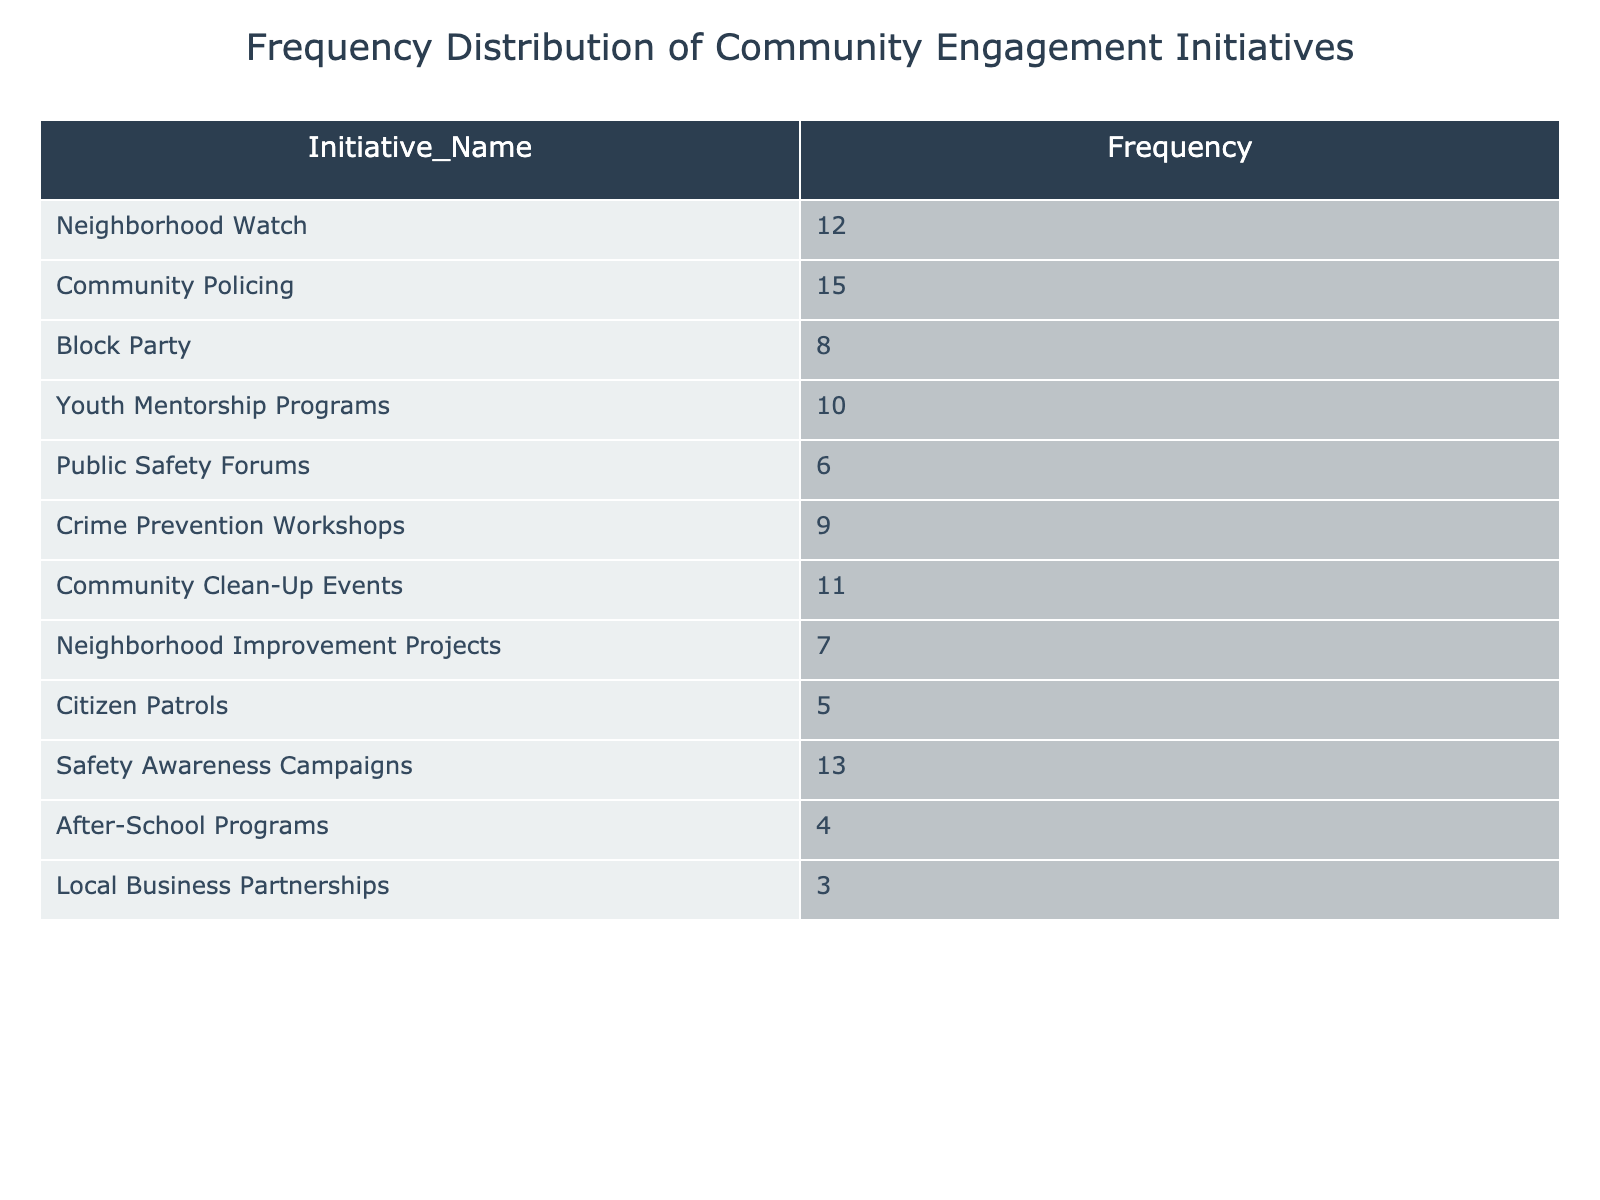What is the initiative with the highest frequency? By inspecting the 'Frequency' column, we can find that 'Community Policing' has the highest frequency value of 15, indicating it is the most engaged initiative.
Answer: Community Policing How many initiatives have a frequency of 10 or more? We can filter the initiatives with a frequency of 10 or more by looking at each value in the 'Frequency' column. The eligible initiatives are 'Neighborhood Watch', 'Community Policing', 'Safety Awareness Campaigns', 'Youth Mentorship Programs', and 'Community Clean-Up Events', totaling 5.
Answer: 5 What is the difference in frequency between the most and least frequent initiatives? The most frequent initiative is 'Community Policing' with a frequency of 15, and the least frequent initiative is 'Local Business Partnerships' with a frequency of 3. The difference is calculated as 15 - 3 = 12.
Answer: 12 Is there an initiative with a frequency equal to the median frequency of all initiatives? To find if there is an initiative with a frequency equal to the median, first, we list frequencies: 3, 4, 5, 6, 7, 8, 9, 10, 11, 12, 13, 15. There are 12 values, so the median is the average of 9 and 10, which is 9.5. The closest frequencies are 9 (Crime Prevention Workshops) and 10 (Youth Mentorship Programs). Therefore, no initiative has a frequency exactly equal to the median.
Answer: No What percentage of the total initiatives does the 'Block Party' represent? First, we sum all the frequencies: 12 + 15 + 8 + 10 + 6 + 9 + 11 + 7 + 5 + 13 + 4 + 3 =  3 + 4 + 5 + 6 + 7 + 8 + 9 + 10 + 11 + 12 + 13 + 15 =  100. 'Block Party' has a frequency of 8. To find the percentage, we use the formula (8 / 100) * 100 = 8%.
Answer: 8% Which two initiatives have a combined frequency of less than 10? We can analyze the frequencies under 10: 'After-School Programs' (4), 'Citizen Patrols' (5), 'Local Business Partnerships' (3), 'Public Safety Forums' (6), and 'Neighborhood Improvement Projects' (7). The pairs can be (3 and 6), (3 and 4), (4 and 5), etc. The pair 'After-School Programs' and 'Local Business Partnerships' (4 + 3 = 7) is one such combination under 10.
Answer: After-School Programs and Local Business Partnerships 